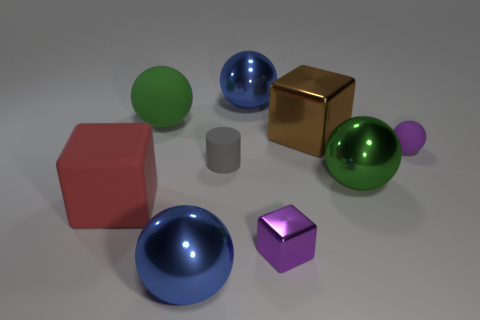There is a metal sphere that is in front of the big rubber block; does it have the same size as the purple thing that is behind the small gray rubber cylinder?
Your answer should be very brief. No. Is there anything else of the same color as the tiny shiny thing?
Your answer should be compact. Yes. The gray matte thing is what size?
Make the answer very short. Small. What shape is the matte object that is the same color as the tiny metallic object?
Ensure brevity in your answer.  Sphere. There is a sphere that is behind the gray cylinder and to the right of the purple metallic thing; what material is it?
Ensure brevity in your answer.  Rubber. The metal sphere that is the same color as the large matte ball is what size?
Offer a terse response. Large. There is a metallic block that is behind the green sphere in front of the tiny gray thing; what is its color?
Provide a succinct answer. Brown. What number of things are brown blocks or purple things that are behind the big red thing?
Provide a short and direct response. 2. Are there any large shiny spheres of the same color as the large matte sphere?
Offer a very short reply. Yes. How many green things are either small spheres or metallic balls?
Your response must be concise. 1. 